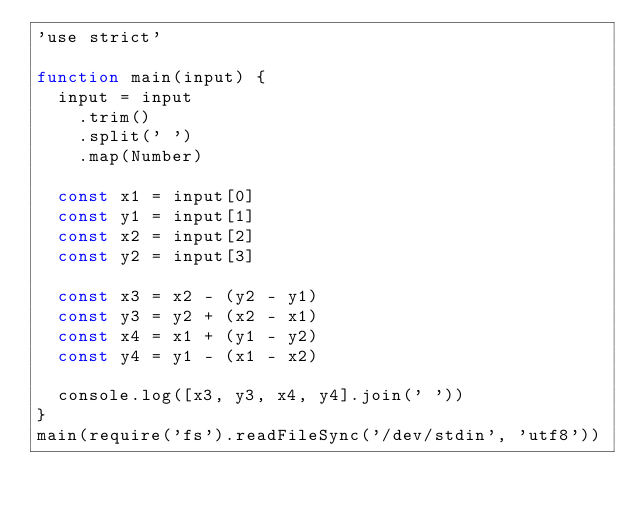<code> <loc_0><loc_0><loc_500><loc_500><_JavaScript_>'use strict'

function main(input) {
  input = input
    .trim()
    .split(' ')
    .map(Number)

  const x1 = input[0]
  const y1 = input[1]
  const x2 = input[2]
  const y2 = input[3]

  const x3 = x2 - (y2 - y1)
  const y3 = y2 + (x2 - x1)
  const x4 = x1 + (y1 - y2)
  const y4 = y1 - (x1 - x2)

  console.log([x3, y3, x4, y4].join(' '))
}
main(require('fs').readFileSync('/dev/stdin', 'utf8'))
</code> 